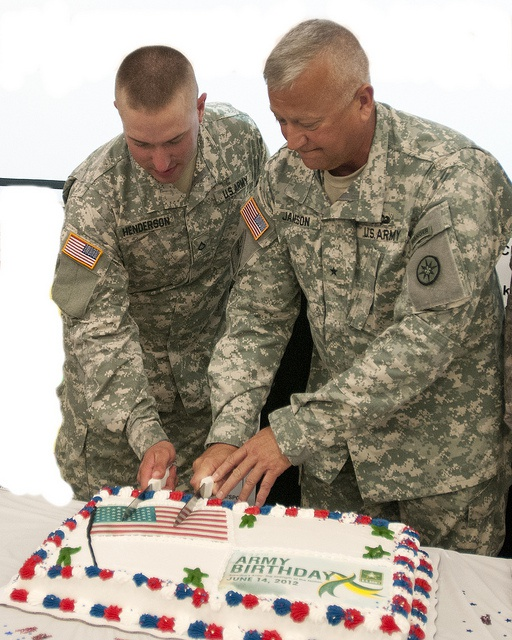Describe the objects in this image and their specific colors. I can see people in white and gray tones, people in white, gray, and black tones, cake in white, ivory, tan, darkgray, and gray tones, dining table in white, lightgray, and darkgray tones, and knife in white, tan, and gray tones in this image. 